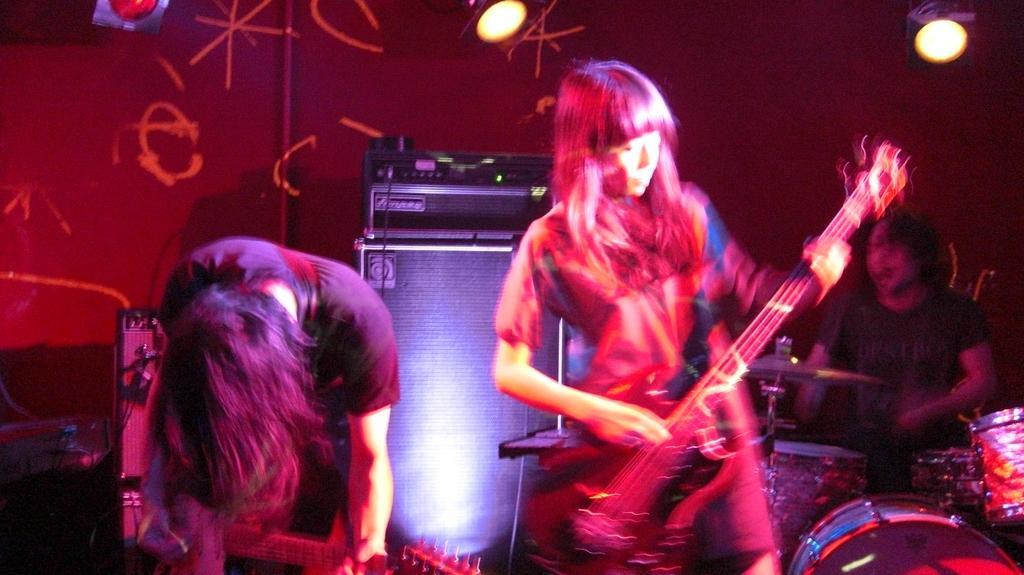Could you give a brief overview of what you see in this image? Woman playing guitar,in the background there is light,this person is playing drum. 